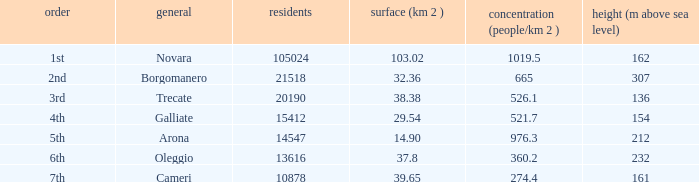Which common has an area (km2) of 38.38? Trecate. 